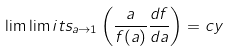Convert formula to latex. <formula><loc_0><loc_0><loc_500><loc_500>\lim \lim i t s _ { a \rightarrow 1 } \left ( \frac { a } { f ( a ) } \frac { d f } { d a } \right ) = c y</formula> 